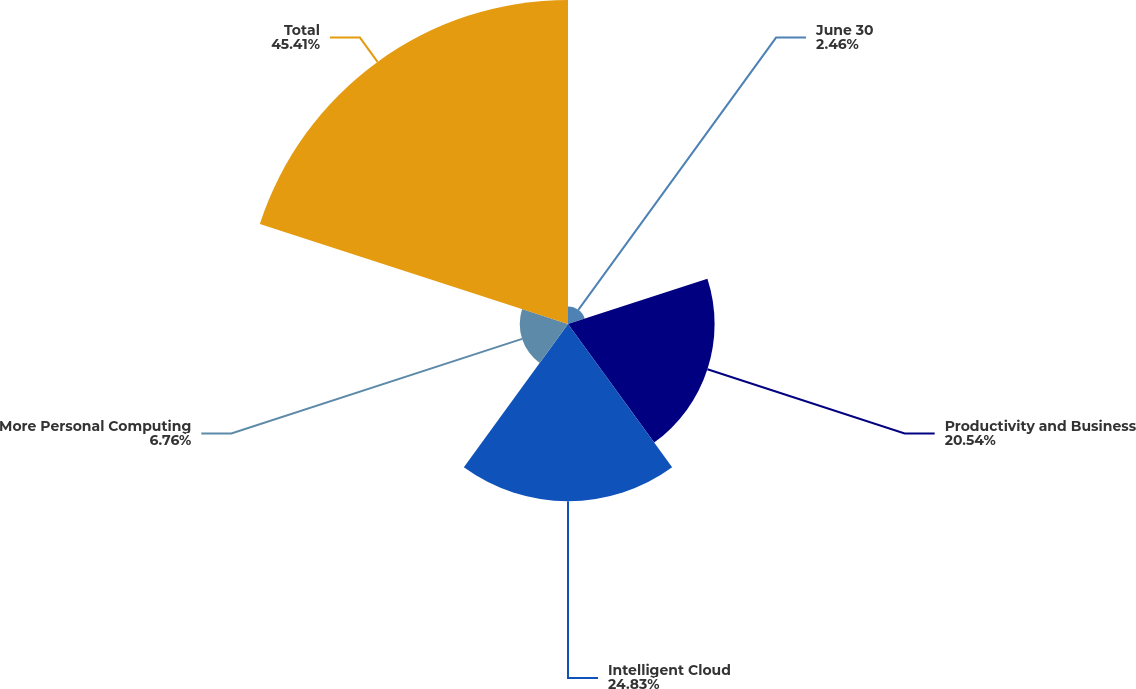<chart> <loc_0><loc_0><loc_500><loc_500><pie_chart><fcel>June 30<fcel>Productivity and Business<fcel>Intelligent Cloud<fcel>More Personal Computing<fcel>Total<nl><fcel>2.46%<fcel>20.54%<fcel>24.83%<fcel>6.76%<fcel>45.4%<nl></chart> 